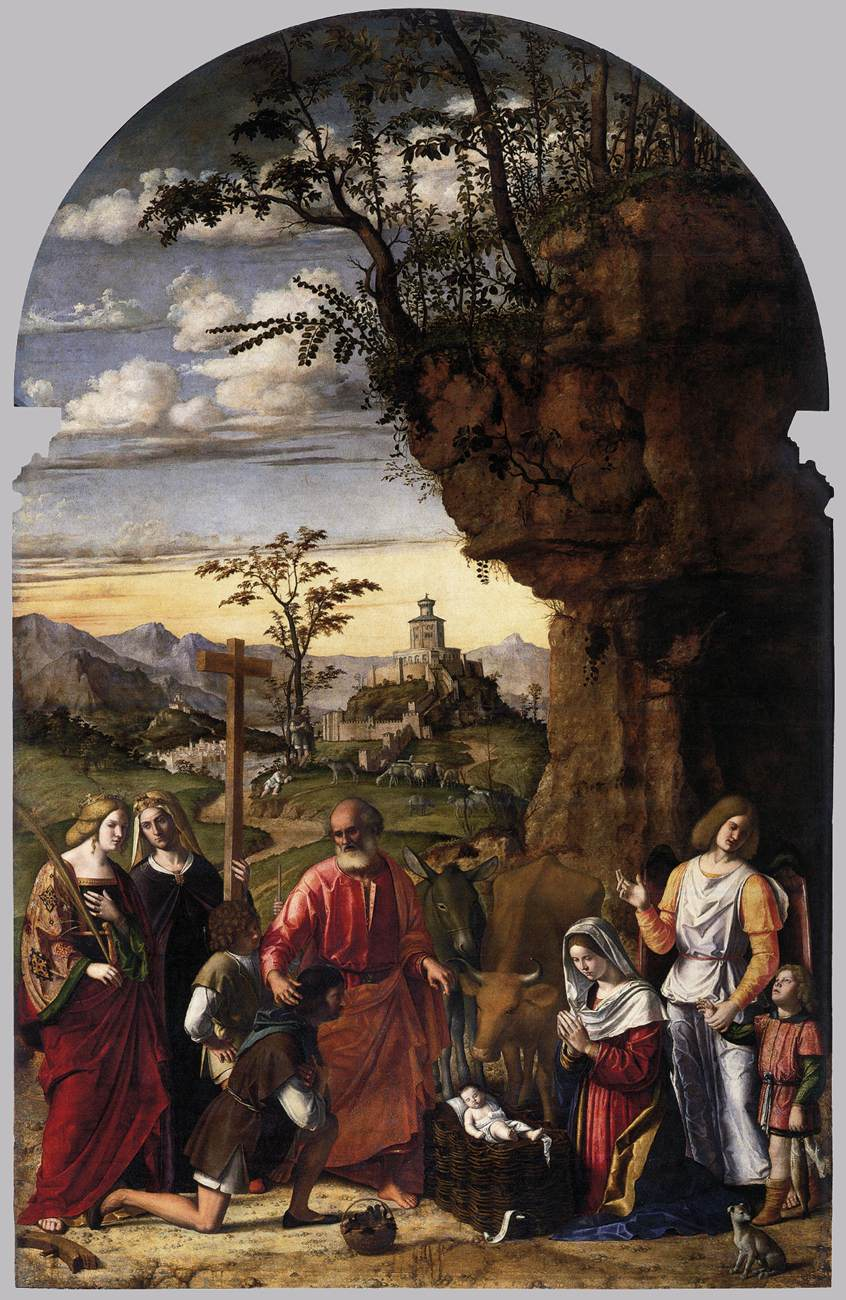Who are the main figures in this painting and what might their individual roles be in this scene? The main figures in this painting represent biblical characters from the Nativity scene. At the center, dressed in ornately colored robes, is Mary, the mother of Jesus, kneeling beside the Christ Child who is laying in a basket. Joseph stands nearby, identifiable by his age and paternal demeanor. Angelic figures are present, symbolizing divine intervention and reverence. Each figure's role varies from divine participants like the angels to familial figures like Mary and Joseph, all gathered to honor the birth of Jesus. What can we infer about the setting and its significance? The setting, featuring a towering cliff and a distant town amidst a natural landscape, provides a visual representation rich with symbolic meaning. The elevated town and the vast landscape suggest the dichotomy of the divine and earthly realms. The cliff might symbolize steadfast faith, while the expansive scenery hints at the far-reaching impact of Christ's birth. This use of natural elements to frame a religious scene serves to magnify the narrative's spiritual dimensions. 